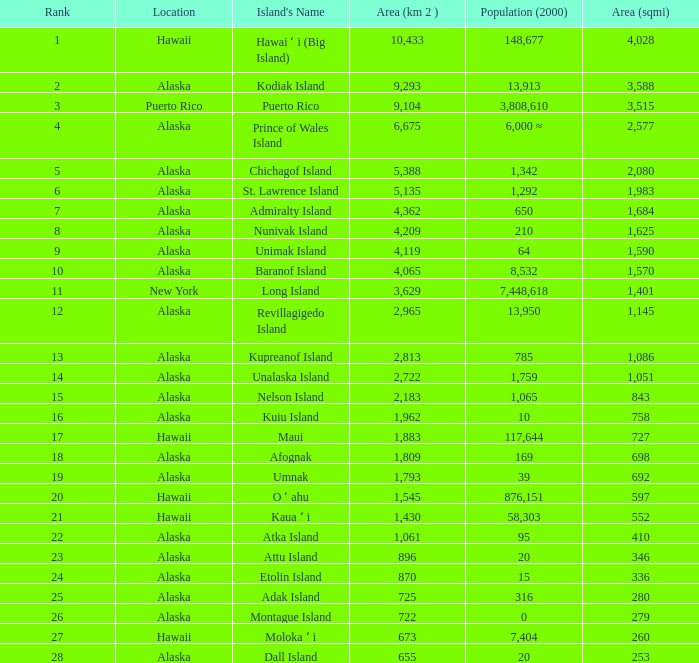What is the largest rank with 2,080 area? 5.0. 